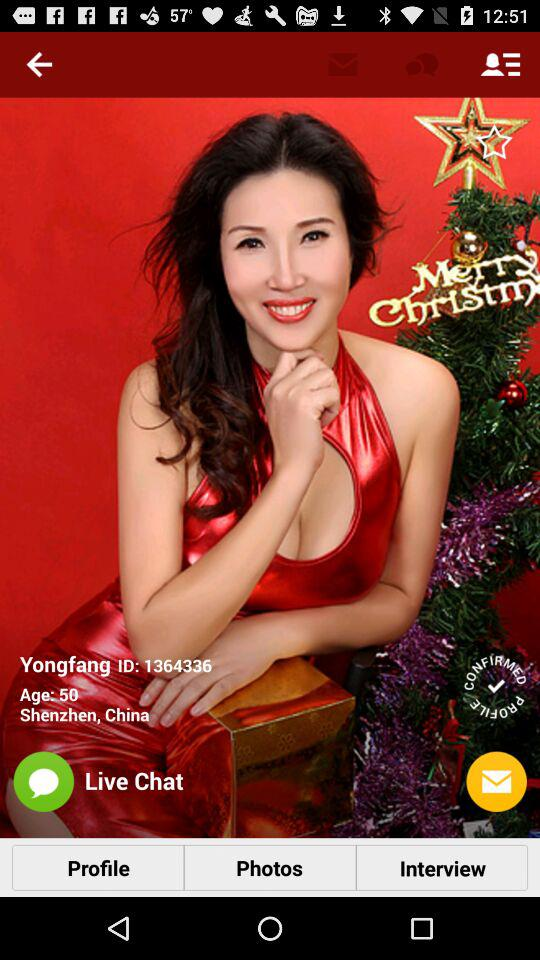What is the location? The location is "Shenzhen, China". 